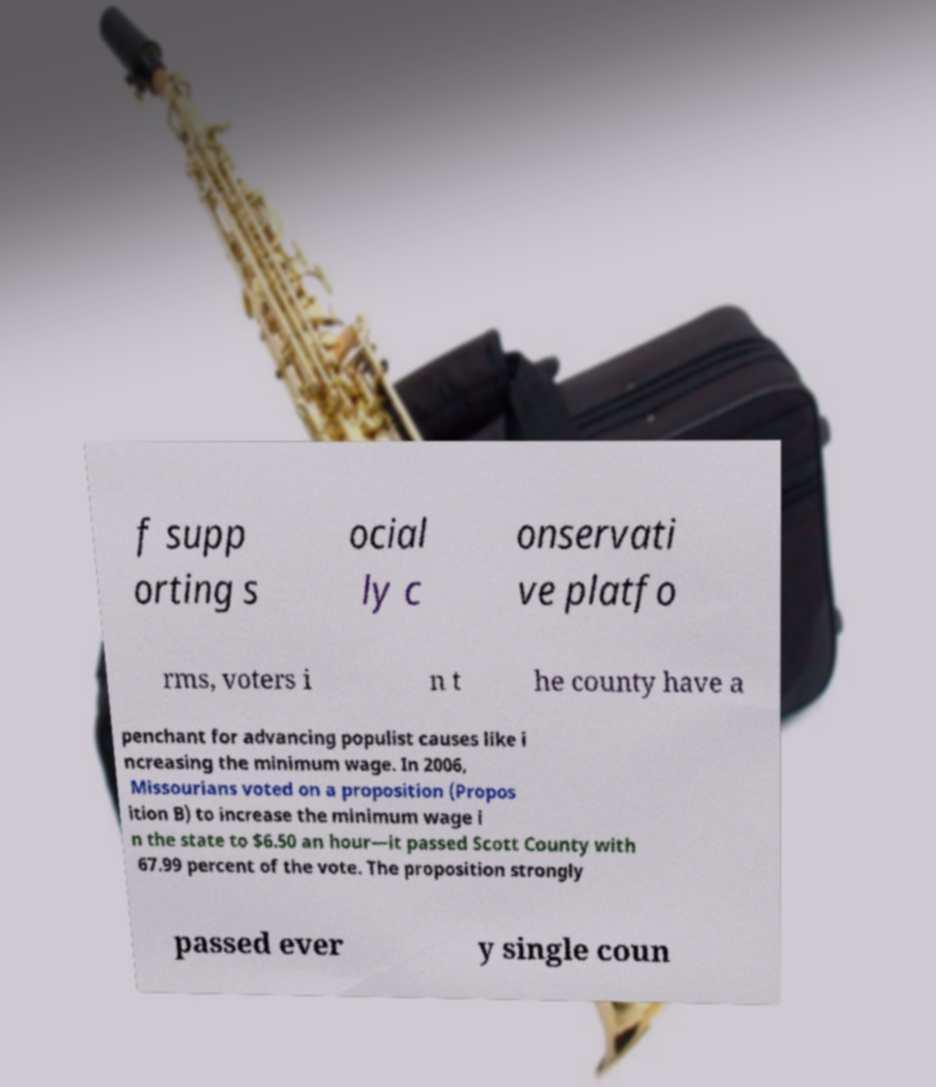Could you assist in decoding the text presented in this image and type it out clearly? f supp orting s ocial ly c onservati ve platfo rms, voters i n t he county have a penchant for advancing populist causes like i ncreasing the minimum wage. In 2006, Missourians voted on a proposition (Propos ition B) to increase the minimum wage i n the state to $6.50 an hour—it passed Scott County with 67.99 percent of the vote. The proposition strongly passed ever y single coun 